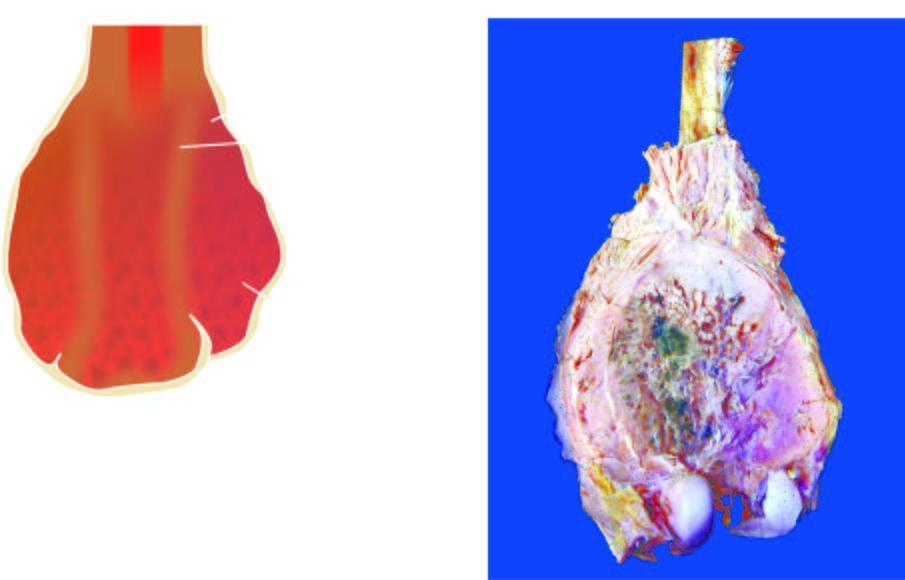does the lower end of the femur show a bulky expanded tumour in the region of metaphysis sparing the epiphyseal cartilage?
Answer the question using a single word or phrase. Yes 